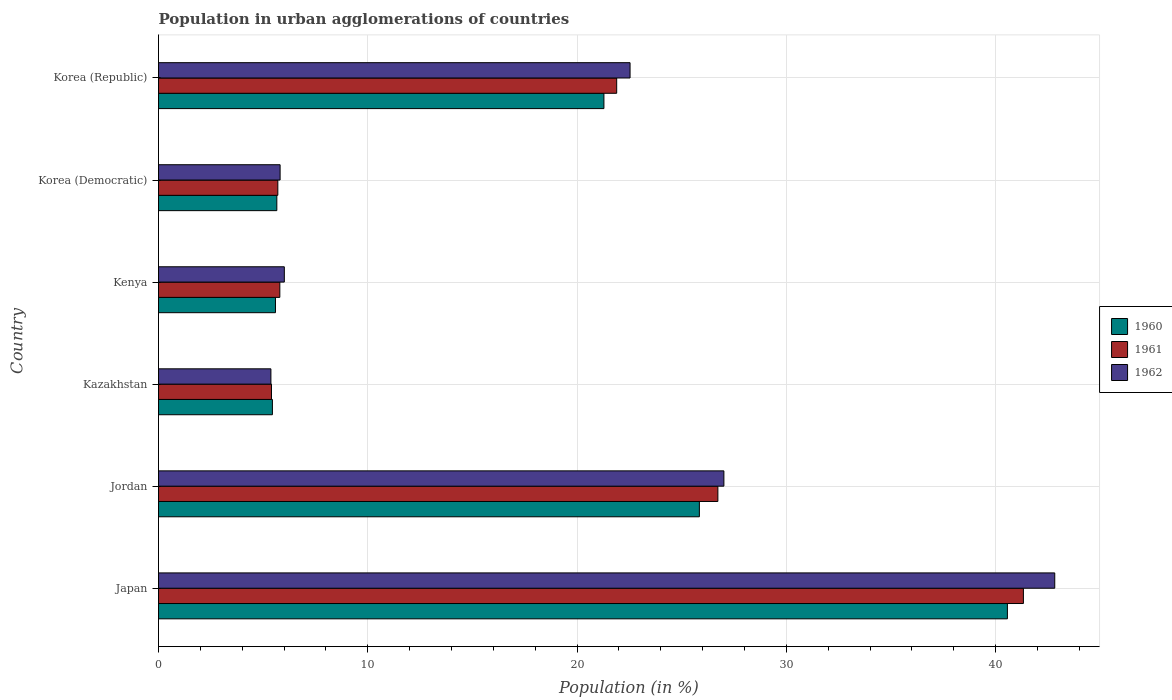How many different coloured bars are there?
Provide a succinct answer. 3. How many groups of bars are there?
Make the answer very short. 6. How many bars are there on the 4th tick from the top?
Provide a short and direct response. 3. How many bars are there on the 5th tick from the bottom?
Provide a short and direct response. 3. What is the label of the 5th group of bars from the top?
Provide a short and direct response. Jordan. What is the percentage of population in urban agglomerations in 1961 in Korea (Democratic)?
Provide a short and direct response. 5.7. Across all countries, what is the maximum percentage of population in urban agglomerations in 1962?
Offer a terse response. 42.82. Across all countries, what is the minimum percentage of population in urban agglomerations in 1962?
Offer a very short reply. 5.37. In which country was the percentage of population in urban agglomerations in 1962 minimum?
Keep it short and to the point. Kazakhstan. What is the total percentage of population in urban agglomerations in 1960 in the graph?
Provide a succinct answer. 104.37. What is the difference between the percentage of population in urban agglomerations in 1962 in Japan and that in Kenya?
Your response must be concise. 36.81. What is the difference between the percentage of population in urban agglomerations in 1961 in Korea (Democratic) and the percentage of population in urban agglomerations in 1960 in Jordan?
Ensure brevity in your answer.  -20.14. What is the average percentage of population in urban agglomerations in 1961 per country?
Keep it short and to the point. 17.81. What is the difference between the percentage of population in urban agglomerations in 1961 and percentage of population in urban agglomerations in 1962 in Jordan?
Your answer should be very brief. -0.29. In how many countries, is the percentage of population in urban agglomerations in 1961 greater than 28 %?
Give a very brief answer. 1. What is the ratio of the percentage of population in urban agglomerations in 1960 in Jordan to that in Korea (Republic)?
Make the answer very short. 1.21. Is the difference between the percentage of population in urban agglomerations in 1961 in Kazakhstan and Korea (Democratic) greater than the difference between the percentage of population in urban agglomerations in 1962 in Kazakhstan and Korea (Democratic)?
Offer a terse response. Yes. What is the difference between the highest and the second highest percentage of population in urban agglomerations in 1960?
Make the answer very short. 14.72. What is the difference between the highest and the lowest percentage of population in urban agglomerations in 1961?
Give a very brief answer. 35.93. In how many countries, is the percentage of population in urban agglomerations in 1960 greater than the average percentage of population in urban agglomerations in 1960 taken over all countries?
Offer a very short reply. 3. Is the sum of the percentage of population in urban agglomerations in 1962 in Korea (Democratic) and Korea (Republic) greater than the maximum percentage of population in urban agglomerations in 1961 across all countries?
Offer a terse response. No. What does the 1st bar from the bottom in Japan represents?
Offer a very short reply. 1960. Is it the case that in every country, the sum of the percentage of population in urban agglomerations in 1961 and percentage of population in urban agglomerations in 1960 is greater than the percentage of population in urban agglomerations in 1962?
Give a very brief answer. Yes. How many bars are there?
Make the answer very short. 18. Does the graph contain any zero values?
Your answer should be very brief. No. Does the graph contain grids?
Your answer should be compact. Yes. How are the legend labels stacked?
Provide a short and direct response. Vertical. What is the title of the graph?
Offer a terse response. Population in urban agglomerations of countries. Does "2012" appear as one of the legend labels in the graph?
Keep it short and to the point. No. What is the label or title of the X-axis?
Your response must be concise. Population (in %). What is the Population (in %) in 1960 in Japan?
Your response must be concise. 40.56. What is the Population (in %) of 1961 in Japan?
Your answer should be compact. 41.33. What is the Population (in %) of 1962 in Japan?
Provide a short and direct response. 42.82. What is the Population (in %) of 1960 in Jordan?
Make the answer very short. 25.84. What is the Population (in %) of 1961 in Jordan?
Offer a very short reply. 26.73. What is the Population (in %) in 1962 in Jordan?
Offer a terse response. 27.01. What is the Population (in %) in 1960 in Kazakhstan?
Keep it short and to the point. 5.44. What is the Population (in %) of 1961 in Kazakhstan?
Keep it short and to the point. 5.4. What is the Population (in %) in 1962 in Kazakhstan?
Make the answer very short. 5.37. What is the Population (in %) in 1960 in Kenya?
Provide a succinct answer. 5.59. What is the Population (in %) in 1961 in Kenya?
Your answer should be very brief. 5.8. What is the Population (in %) of 1962 in Kenya?
Ensure brevity in your answer.  6.01. What is the Population (in %) of 1960 in Korea (Democratic)?
Provide a succinct answer. 5.65. What is the Population (in %) of 1961 in Korea (Democratic)?
Make the answer very short. 5.7. What is the Population (in %) of 1962 in Korea (Democratic)?
Your answer should be compact. 5.81. What is the Population (in %) of 1960 in Korea (Republic)?
Make the answer very short. 21.28. What is the Population (in %) of 1961 in Korea (Republic)?
Your response must be concise. 21.89. What is the Population (in %) in 1962 in Korea (Republic)?
Give a very brief answer. 22.53. Across all countries, what is the maximum Population (in %) in 1960?
Provide a short and direct response. 40.56. Across all countries, what is the maximum Population (in %) in 1961?
Ensure brevity in your answer.  41.33. Across all countries, what is the maximum Population (in %) in 1962?
Provide a short and direct response. 42.82. Across all countries, what is the minimum Population (in %) in 1960?
Keep it short and to the point. 5.44. Across all countries, what is the minimum Population (in %) in 1961?
Offer a very short reply. 5.4. Across all countries, what is the minimum Population (in %) of 1962?
Provide a succinct answer. 5.37. What is the total Population (in %) in 1960 in the graph?
Your answer should be very brief. 104.37. What is the total Population (in %) of 1961 in the graph?
Your answer should be very brief. 106.84. What is the total Population (in %) in 1962 in the graph?
Give a very brief answer. 109.56. What is the difference between the Population (in %) of 1960 in Japan and that in Jordan?
Your response must be concise. 14.72. What is the difference between the Population (in %) in 1961 in Japan and that in Jordan?
Your response must be concise. 14.6. What is the difference between the Population (in %) in 1962 in Japan and that in Jordan?
Offer a terse response. 15.81. What is the difference between the Population (in %) in 1960 in Japan and that in Kazakhstan?
Provide a succinct answer. 35.12. What is the difference between the Population (in %) in 1961 in Japan and that in Kazakhstan?
Your answer should be very brief. 35.93. What is the difference between the Population (in %) in 1962 in Japan and that in Kazakhstan?
Give a very brief answer. 37.45. What is the difference between the Population (in %) in 1960 in Japan and that in Kenya?
Ensure brevity in your answer.  34.97. What is the difference between the Population (in %) of 1961 in Japan and that in Kenya?
Offer a very short reply. 35.53. What is the difference between the Population (in %) in 1962 in Japan and that in Kenya?
Your answer should be very brief. 36.81. What is the difference between the Population (in %) in 1960 in Japan and that in Korea (Democratic)?
Provide a succinct answer. 34.91. What is the difference between the Population (in %) of 1961 in Japan and that in Korea (Democratic)?
Offer a very short reply. 35.62. What is the difference between the Population (in %) of 1962 in Japan and that in Korea (Democratic)?
Your answer should be very brief. 37.01. What is the difference between the Population (in %) in 1960 in Japan and that in Korea (Republic)?
Offer a terse response. 19.28. What is the difference between the Population (in %) in 1961 in Japan and that in Korea (Republic)?
Offer a terse response. 19.43. What is the difference between the Population (in %) of 1962 in Japan and that in Korea (Republic)?
Offer a very short reply. 20.29. What is the difference between the Population (in %) in 1960 in Jordan and that in Kazakhstan?
Keep it short and to the point. 20.4. What is the difference between the Population (in %) in 1961 in Jordan and that in Kazakhstan?
Your response must be concise. 21.33. What is the difference between the Population (in %) of 1962 in Jordan and that in Kazakhstan?
Your answer should be very brief. 21.64. What is the difference between the Population (in %) in 1960 in Jordan and that in Kenya?
Offer a very short reply. 20.25. What is the difference between the Population (in %) in 1961 in Jordan and that in Kenya?
Give a very brief answer. 20.93. What is the difference between the Population (in %) of 1962 in Jordan and that in Kenya?
Provide a short and direct response. 21. What is the difference between the Population (in %) in 1960 in Jordan and that in Korea (Democratic)?
Give a very brief answer. 20.19. What is the difference between the Population (in %) in 1961 in Jordan and that in Korea (Democratic)?
Keep it short and to the point. 21.03. What is the difference between the Population (in %) of 1962 in Jordan and that in Korea (Democratic)?
Offer a very short reply. 21.2. What is the difference between the Population (in %) of 1960 in Jordan and that in Korea (Republic)?
Your answer should be very brief. 4.56. What is the difference between the Population (in %) in 1961 in Jordan and that in Korea (Republic)?
Provide a succinct answer. 4.84. What is the difference between the Population (in %) in 1962 in Jordan and that in Korea (Republic)?
Make the answer very short. 4.48. What is the difference between the Population (in %) in 1960 in Kazakhstan and that in Kenya?
Offer a very short reply. -0.15. What is the difference between the Population (in %) of 1961 in Kazakhstan and that in Kenya?
Make the answer very short. -0.4. What is the difference between the Population (in %) in 1962 in Kazakhstan and that in Kenya?
Keep it short and to the point. -0.64. What is the difference between the Population (in %) of 1960 in Kazakhstan and that in Korea (Democratic)?
Your answer should be very brief. -0.21. What is the difference between the Population (in %) of 1961 in Kazakhstan and that in Korea (Democratic)?
Your answer should be very brief. -0.3. What is the difference between the Population (in %) in 1962 in Kazakhstan and that in Korea (Democratic)?
Keep it short and to the point. -0.44. What is the difference between the Population (in %) in 1960 in Kazakhstan and that in Korea (Republic)?
Provide a short and direct response. -15.84. What is the difference between the Population (in %) in 1961 in Kazakhstan and that in Korea (Republic)?
Give a very brief answer. -16.49. What is the difference between the Population (in %) of 1962 in Kazakhstan and that in Korea (Republic)?
Ensure brevity in your answer.  -17.16. What is the difference between the Population (in %) in 1960 in Kenya and that in Korea (Democratic)?
Ensure brevity in your answer.  -0.07. What is the difference between the Population (in %) of 1961 in Kenya and that in Korea (Democratic)?
Give a very brief answer. 0.1. What is the difference between the Population (in %) of 1962 in Kenya and that in Korea (Democratic)?
Provide a short and direct response. 0.2. What is the difference between the Population (in %) of 1960 in Kenya and that in Korea (Republic)?
Ensure brevity in your answer.  -15.69. What is the difference between the Population (in %) in 1961 in Kenya and that in Korea (Republic)?
Give a very brief answer. -16.1. What is the difference between the Population (in %) in 1962 in Kenya and that in Korea (Republic)?
Provide a succinct answer. -16.52. What is the difference between the Population (in %) in 1960 in Korea (Democratic) and that in Korea (Republic)?
Ensure brevity in your answer.  -15.63. What is the difference between the Population (in %) of 1961 in Korea (Democratic) and that in Korea (Republic)?
Your answer should be very brief. -16.19. What is the difference between the Population (in %) of 1962 in Korea (Democratic) and that in Korea (Republic)?
Offer a very short reply. -16.72. What is the difference between the Population (in %) in 1960 in Japan and the Population (in %) in 1961 in Jordan?
Provide a succinct answer. 13.83. What is the difference between the Population (in %) of 1960 in Japan and the Population (in %) of 1962 in Jordan?
Your response must be concise. 13.55. What is the difference between the Population (in %) in 1961 in Japan and the Population (in %) in 1962 in Jordan?
Provide a succinct answer. 14.31. What is the difference between the Population (in %) of 1960 in Japan and the Population (in %) of 1961 in Kazakhstan?
Offer a terse response. 35.16. What is the difference between the Population (in %) of 1960 in Japan and the Population (in %) of 1962 in Kazakhstan?
Your answer should be compact. 35.19. What is the difference between the Population (in %) of 1961 in Japan and the Population (in %) of 1962 in Kazakhstan?
Your response must be concise. 35.95. What is the difference between the Population (in %) in 1960 in Japan and the Population (in %) in 1961 in Kenya?
Your answer should be compact. 34.76. What is the difference between the Population (in %) of 1960 in Japan and the Population (in %) of 1962 in Kenya?
Give a very brief answer. 34.55. What is the difference between the Population (in %) in 1961 in Japan and the Population (in %) in 1962 in Kenya?
Keep it short and to the point. 35.31. What is the difference between the Population (in %) of 1960 in Japan and the Population (in %) of 1961 in Korea (Democratic)?
Provide a succinct answer. 34.86. What is the difference between the Population (in %) of 1960 in Japan and the Population (in %) of 1962 in Korea (Democratic)?
Make the answer very short. 34.75. What is the difference between the Population (in %) in 1961 in Japan and the Population (in %) in 1962 in Korea (Democratic)?
Your response must be concise. 35.52. What is the difference between the Population (in %) of 1960 in Japan and the Population (in %) of 1961 in Korea (Republic)?
Give a very brief answer. 18.67. What is the difference between the Population (in %) in 1960 in Japan and the Population (in %) in 1962 in Korea (Republic)?
Offer a very short reply. 18.03. What is the difference between the Population (in %) of 1961 in Japan and the Population (in %) of 1962 in Korea (Republic)?
Ensure brevity in your answer.  18.79. What is the difference between the Population (in %) in 1960 in Jordan and the Population (in %) in 1961 in Kazakhstan?
Offer a terse response. 20.44. What is the difference between the Population (in %) in 1960 in Jordan and the Population (in %) in 1962 in Kazakhstan?
Your answer should be compact. 20.47. What is the difference between the Population (in %) of 1961 in Jordan and the Population (in %) of 1962 in Kazakhstan?
Make the answer very short. 21.36. What is the difference between the Population (in %) of 1960 in Jordan and the Population (in %) of 1961 in Kenya?
Your answer should be very brief. 20.05. What is the difference between the Population (in %) of 1960 in Jordan and the Population (in %) of 1962 in Kenya?
Provide a succinct answer. 19.83. What is the difference between the Population (in %) in 1961 in Jordan and the Population (in %) in 1962 in Kenya?
Offer a terse response. 20.72. What is the difference between the Population (in %) in 1960 in Jordan and the Population (in %) in 1961 in Korea (Democratic)?
Make the answer very short. 20.14. What is the difference between the Population (in %) of 1960 in Jordan and the Population (in %) of 1962 in Korea (Democratic)?
Ensure brevity in your answer.  20.03. What is the difference between the Population (in %) in 1961 in Jordan and the Population (in %) in 1962 in Korea (Democratic)?
Offer a terse response. 20.92. What is the difference between the Population (in %) in 1960 in Jordan and the Population (in %) in 1961 in Korea (Republic)?
Ensure brevity in your answer.  3.95. What is the difference between the Population (in %) of 1960 in Jordan and the Population (in %) of 1962 in Korea (Republic)?
Provide a succinct answer. 3.31. What is the difference between the Population (in %) of 1961 in Jordan and the Population (in %) of 1962 in Korea (Republic)?
Give a very brief answer. 4.2. What is the difference between the Population (in %) in 1960 in Kazakhstan and the Population (in %) in 1961 in Kenya?
Make the answer very short. -0.35. What is the difference between the Population (in %) in 1960 in Kazakhstan and the Population (in %) in 1962 in Kenya?
Offer a very short reply. -0.57. What is the difference between the Population (in %) in 1961 in Kazakhstan and the Population (in %) in 1962 in Kenya?
Your answer should be very brief. -0.61. What is the difference between the Population (in %) of 1960 in Kazakhstan and the Population (in %) of 1961 in Korea (Democratic)?
Provide a short and direct response. -0.26. What is the difference between the Population (in %) of 1960 in Kazakhstan and the Population (in %) of 1962 in Korea (Democratic)?
Offer a terse response. -0.37. What is the difference between the Population (in %) in 1961 in Kazakhstan and the Population (in %) in 1962 in Korea (Democratic)?
Offer a terse response. -0.41. What is the difference between the Population (in %) of 1960 in Kazakhstan and the Population (in %) of 1961 in Korea (Republic)?
Make the answer very short. -16.45. What is the difference between the Population (in %) of 1960 in Kazakhstan and the Population (in %) of 1962 in Korea (Republic)?
Provide a succinct answer. -17.09. What is the difference between the Population (in %) of 1961 in Kazakhstan and the Population (in %) of 1962 in Korea (Republic)?
Give a very brief answer. -17.13. What is the difference between the Population (in %) of 1960 in Kenya and the Population (in %) of 1961 in Korea (Democratic)?
Your answer should be compact. -0.11. What is the difference between the Population (in %) in 1960 in Kenya and the Population (in %) in 1962 in Korea (Democratic)?
Your response must be concise. -0.22. What is the difference between the Population (in %) of 1961 in Kenya and the Population (in %) of 1962 in Korea (Democratic)?
Your answer should be very brief. -0.01. What is the difference between the Population (in %) of 1960 in Kenya and the Population (in %) of 1961 in Korea (Republic)?
Your answer should be very brief. -16.3. What is the difference between the Population (in %) in 1960 in Kenya and the Population (in %) in 1962 in Korea (Republic)?
Offer a terse response. -16.94. What is the difference between the Population (in %) of 1961 in Kenya and the Population (in %) of 1962 in Korea (Republic)?
Ensure brevity in your answer.  -16.73. What is the difference between the Population (in %) of 1960 in Korea (Democratic) and the Population (in %) of 1961 in Korea (Republic)?
Keep it short and to the point. -16.24. What is the difference between the Population (in %) of 1960 in Korea (Democratic) and the Population (in %) of 1962 in Korea (Republic)?
Offer a very short reply. -16.88. What is the difference between the Population (in %) in 1961 in Korea (Democratic) and the Population (in %) in 1962 in Korea (Republic)?
Your response must be concise. -16.83. What is the average Population (in %) in 1960 per country?
Offer a very short reply. 17.39. What is the average Population (in %) in 1961 per country?
Give a very brief answer. 17.81. What is the average Population (in %) in 1962 per country?
Offer a very short reply. 18.26. What is the difference between the Population (in %) in 1960 and Population (in %) in 1961 in Japan?
Provide a short and direct response. -0.76. What is the difference between the Population (in %) of 1960 and Population (in %) of 1962 in Japan?
Your response must be concise. -2.26. What is the difference between the Population (in %) in 1961 and Population (in %) in 1962 in Japan?
Provide a succinct answer. -1.5. What is the difference between the Population (in %) of 1960 and Population (in %) of 1961 in Jordan?
Your answer should be compact. -0.88. What is the difference between the Population (in %) in 1960 and Population (in %) in 1962 in Jordan?
Your response must be concise. -1.17. What is the difference between the Population (in %) of 1961 and Population (in %) of 1962 in Jordan?
Offer a terse response. -0.29. What is the difference between the Population (in %) of 1960 and Population (in %) of 1961 in Kazakhstan?
Provide a short and direct response. 0.04. What is the difference between the Population (in %) of 1960 and Population (in %) of 1962 in Kazakhstan?
Offer a terse response. 0.07. What is the difference between the Population (in %) in 1961 and Population (in %) in 1962 in Kazakhstan?
Your answer should be compact. 0.03. What is the difference between the Population (in %) of 1960 and Population (in %) of 1961 in Kenya?
Make the answer very short. -0.21. What is the difference between the Population (in %) in 1960 and Population (in %) in 1962 in Kenya?
Ensure brevity in your answer.  -0.42. What is the difference between the Population (in %) of 1961 and Population (in %) of 1962 in Kenya?
Provide a short and direct response. -0.21. What is the difference between the Population (in %) in 1960 and Population (in %) in 1961 in Korea (Democratic)?
Provide a succinct answer. -0.05. What is the difference between the Population (in %) in 1960 and Population (in %) in 1962 in Korea (Democratic)?
Ensure brevity in your answer.  -0.16. What is the difference between the Population (in %) of 1961 and Population (in %) of 1962 in Korea (Democratic)?
Provide a short and direct response. -0.11. What is the difference between the Population (in %) in 1960 and Population (in %) in 1961 in Korea (Republic)?
Provide a short and direct response. -0.61. What is the difference between the Population (in %) in 1960 and Population (in %) in 1962 in Korea (Republic)?
Your answer should be compact. -1.25. What is the difference between the Population (in %) of 1961 and Population (in %) of 1962 in Korea (Republic)?
Keep it short and to the point. -0.64. What is the ratio of the Population (in %) of 1960 in Japan to that in Jordan?
Keep it short and to the point. 1.57. What is the ratio of the Population (in %) in 1961 in Japan to that in Jordan?
Provide a succinct answer. 1.55. What is the ratio of the Population (in %) of 1962 in Japan to that in Jordan?
Provide a succinct answer. 1.59. What is the ratio of the Population (in %) of 1960 in Japan to that in Kazakhstan?
Give a very brief answer. 7.45. What is the ratio of the Population (in %) of 1961 in Japan to that in Kazakhstan?
Make the answer very short. 7.66. What is the ratio of the Population (in %) in 1962 in Japan to that in Kazakhstan?
Offer a terse response. 7.97. What is the ratio of the Population (in %) in 1960 in Japan to that in Kenya?
Provide a short and direct response. 7.26. What is the ratio of the Population (in %) in 1961 in Japan to that in Kenya?
Your answer should be compact. 7.13. What is the ratio of the Population (in %) of 1962 in Japan to that in Kenya?
Your answer should be very brief. 7.12. What is the ratio of the Population (in %) of 1960 in Japan to that in Korea (Democratic)?
Ensure brevity in your answer.  7.17. What is the ratio of the Population (in %) in 1961 in Japan to that in Korea (Democratic)?
Keep it short and to the point. 7.25. What is the ratio of the Population (in %) in 1962 in Japan to that in Korea (Democratic)?
Offer a terse response. 7.37. What is the ratio of the Population (in %) of 1960 in Japan to that in Korea (Republic)?
Your answer should be compact. 1.91. What is the ratio of the Population (in %) in 1961 in Japan to that in Korea (Republic)?
Provide a short and direct response. 1.89. What is the ratio of the Population (in %) in 1962 in Japan to that in Korea (Republic)?
Make the answer very short. 1.9. What is the ratio of the Population (in %) of 1960 in Jordan to that in Kazakhstan?
Give a very brief answer. 4.75. What is the ratio of the Population (in %) of 1961 in Jordan to that in Kazakhstan?
Provide a succinct answer. 4.95. What is the ratio of the Population (in %) of 1962 in Jordan to that in Kazakhstan?
Your response must be concise. 5.03. What is the ratio of the Population (in %) in 1960 in Jordan to that in Kenya?
Ensure brevity in your answer.  4.62. What is the ratio of the Population (in %) in 1961 in Jordan to that in Kenya?
Provide a short and direct response. 4.61. What is the ratio of the Population (in %) in 1962 in Jordan to that in Kenya?
Provide a short and direct response. 4.49. What is the ratio of the Population (in %) in 1960 in Jordan to that in Korea (Democratic)?
Your answer should be very brief. 4.57. What is the ratio of the Population (in %) of 1961 in Jordan to that in Korea (Democratic)?
Your answer should be compact. 4.69. What is the ratio of the Population (in %) in 1962 in Jordan to that in Korea (Democratic)?
Your answer should be very brief. 4.65. What is the ratio of the Population (in %) in 1960 in Jordan to that in Korea (Republic)?
Your answer should be very brief. 1.21. What is the ratio of the Population (in %) of 1961 in Jordan to that in Korea (Republic)?
Provide a short and direct response. 1.22. What is the ratio of the Population (in %) in 1962 in Jordan to that in Korea (Republic)?
Offer a terse response. 1.2. What is the ratio of the Population (in %) of 1960 in Kazakhstan to that in Kenya?
Make the answer very short. 0.97. What is the ratio of the Population (in %) of 1961 in Kazakhstan to that in Kenya?
Offer a very short reply. 0.93. What is the ratio of the Population (in %) of 1962 in Kazakhstan to that in Kenya?
Make the answer very short. 0.89. What is the ratio of the Population (in %) in 1960 in Kazakhstan to that in Korea (Democratic)?
Give a very brief answer. 0.96. What is the ratio of the Population (in %) in 1961 in Kazakhstan to that in Korea (Democratic)?
Make the answer very short. 0.95. What is the ratio of the Population (in %) in 1962 in Kazakhstan to that in Korea (Democratic)?
Your answer should be very brief. 0.92. What is the ratio of the Population (in %) in 1960 in Kazakhstan to that in Korea (Republic)?
Your answer should be very brief. 0.26. What is the ratio of the Population (in %) in 1961 in Kazakhstan to that in Korea (Republic)?
Keep it short and to the point. 0.25. What is the ratio of the Population (in %) in 1962 in Kazakhstan to that in Korea (Republic)?
Offer a terse response. 0.24. What is the ratio of the Population (in %) in 1961 in Kenya to that in Korea (Democratic)?
Keep it short and to the point. 1.02. What is the ratio of the Population (in %) in 1962 in Kenya to that in Korea (Democratic)?
Your answer should be very brief. 1.03. What is the ratio of the Population (in %) in 1960 in Kenya to that in Korea (Republic)?
Offer a very short reply. 0.26. What is the ratio of the Population (in %) of 1961 in Kenya to that in Korea (Republic)?
Make the answer very short. 0.26. What is the ratio of the Population (in %) of 1962 in Kenya to that in Korea (Republic)?
Offer a very short reply. 0.27. What is the ratio of the Population (in %) in 1960 in Korea (Democratic) to that in Korea (Republic)?
Your response must be concise. 0.27. What is the ratio of the Population (in %) in 1961 in Korea (Democratic) to that in Korea (Republic)?
Keep it short and to the point. 0.26. What is the ratio of the Population (in %) of 1962 in Korea (Democratic) to that in Korea (Republic)?
Ensure brevity in your answer.  0.26. What is the difference between the highest and the second highest Population (in %) in 1960?
Ensure brevity in your answer.  14.72. What is the difference between the highest and the second highest Population (in %) of 1961?
Your response must be concise. 14.6. What is the difference between the highest and the second highest Population (in %) in 1962?
Offer a terse response. 15.81. What is the difference between the highest and the lowest Population (in %) in 1960?
Your answer should be very brief. 35.12. What is the difference between the highest and the lowest Population (in %) in 1961?
Your answer should be very brief. 35.93. What is the difference between the highest and the lowest Population (in %) in 1962?
Make the answer very short. 37.45. 